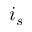Convert formula to latex. <formula><loc_0><loc_0><loc_500><loc_500>i _ { s }</formula> 